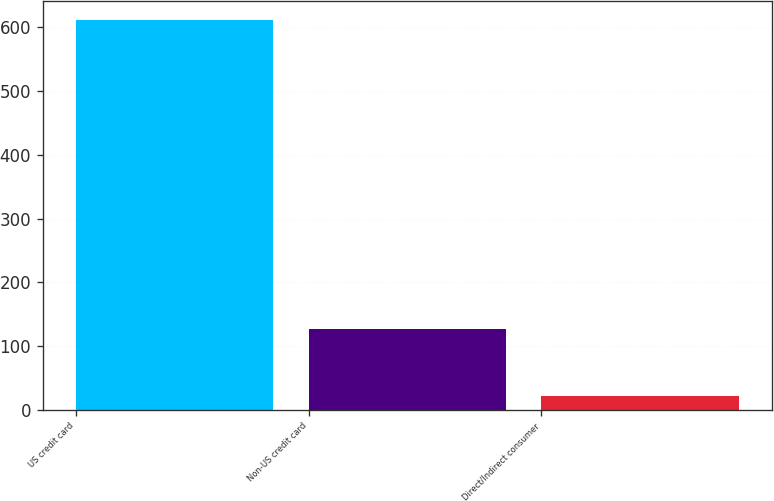Convert chart to OTSL. <chart><loc_0><loc_0><loc_500><loc_500><bar_chart><fcel>US credit card<fcel>Non-US credit card<fcel>Direct/Indirect consumer<nl><fcel>611<fcel>126<fcel>21<nl></chart> 